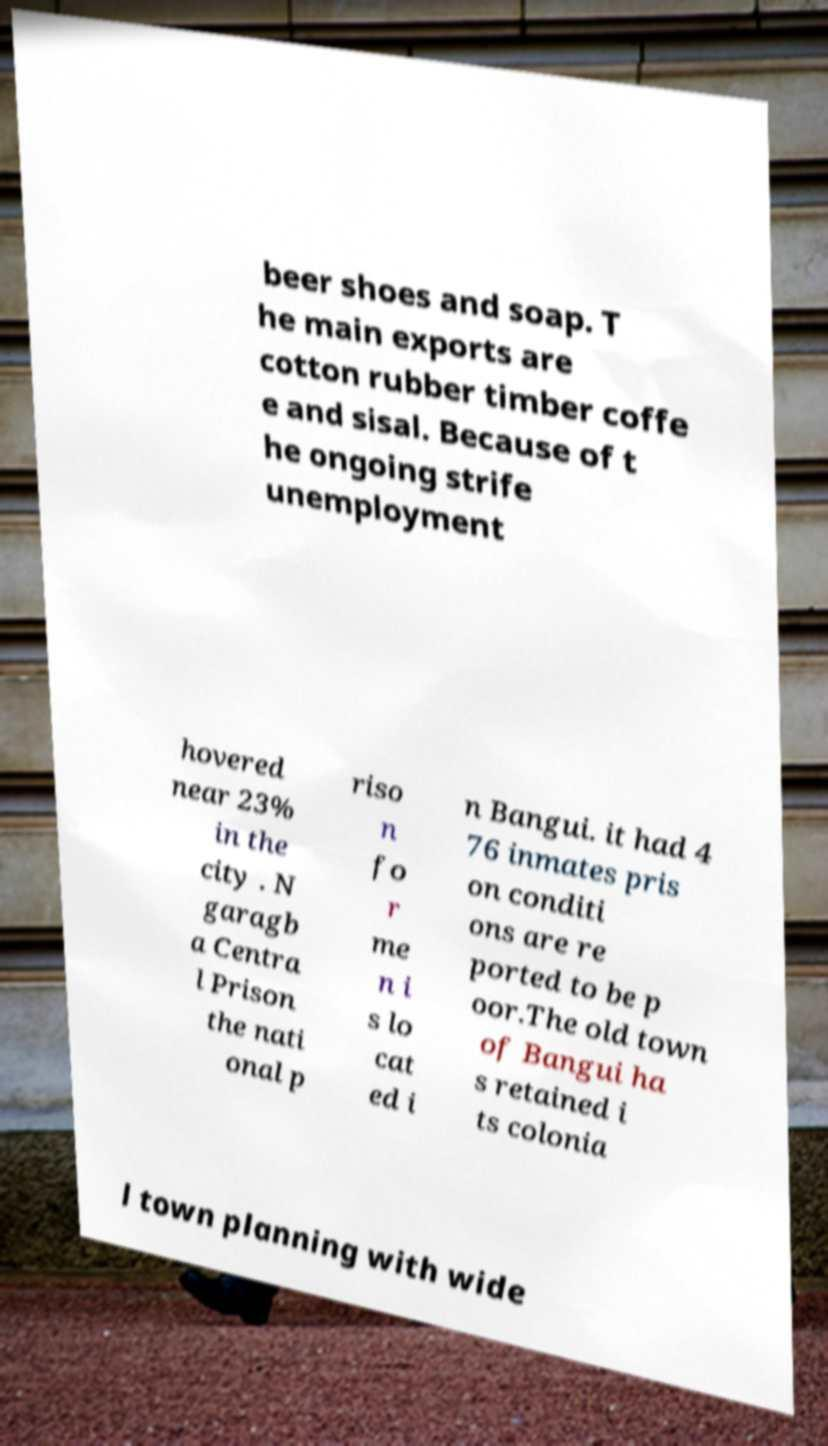Can you read and provide the text displayed in the image?This photo seems to have some interesting text. Can you extract and type it out for me? beer shoes and soap. T he main exports are cotton rubber timber coffe e and sisal. Because of t he ongoing strife unemployment hovered near 23% in the city . N garagb a Centra l Prison the nati onal p riso n fo r me n i s lo cat ed i n Bangui. it had 4 76 inmates pris on conditi ons are re ported to be p oor.The old town of Bangui ha s retained i ts colonia l town planning with wide 